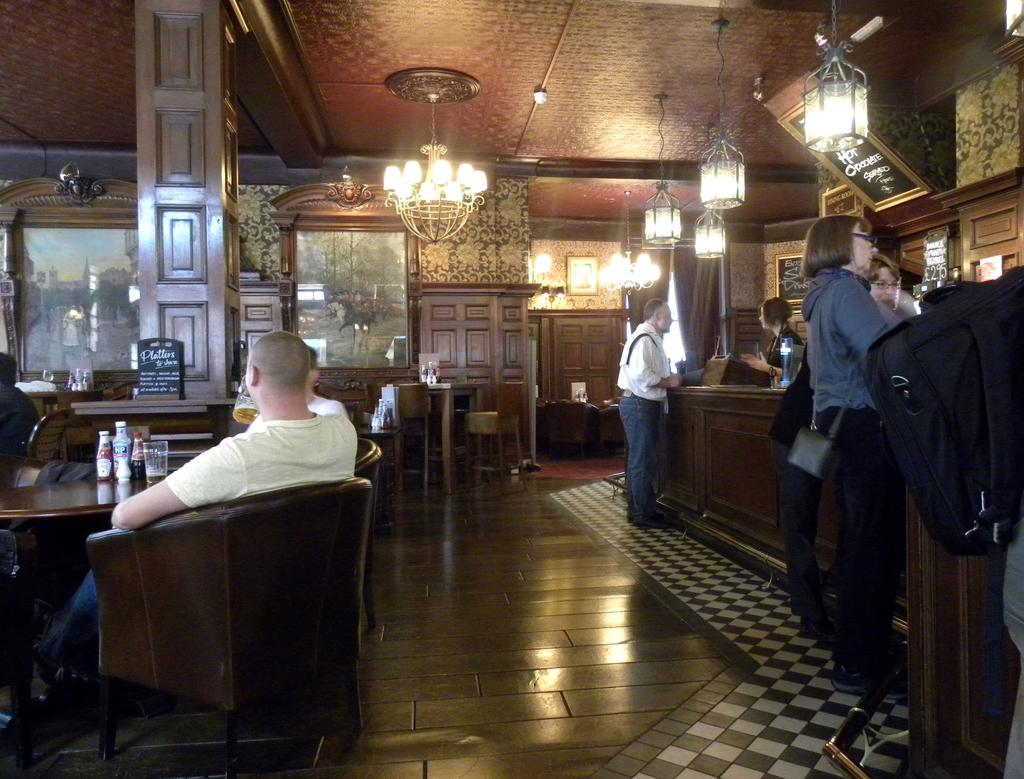How would you summarize this image in a sentence or two? The picture is taken in a bar. On the left there are tables, chairs, glasses, jars, chairs, board, frame and other objects. On the right there are people, desk, frames, lights and other objects. In the center of the background there are frames, chairs, desk, chandeliers, glasses, lights and other objects. 